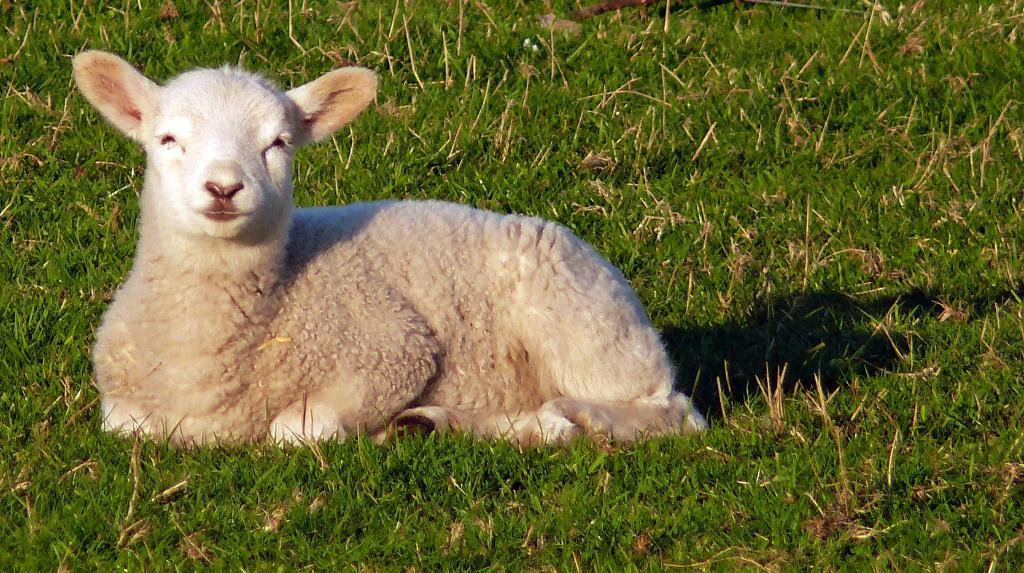What type of animal is present in the image? There is a sheep in the image. What is the sheep standing on in the image? The sheep is on the surface of the grass. What type of paper is the sheep holding in the image? There is no paper present in the image, as it features a sheep standing on the surface of the grass. What type of soda is the sheep drinking in the image? There is no soda present in the image, as it features a sheep standing on the surface of the grass. 